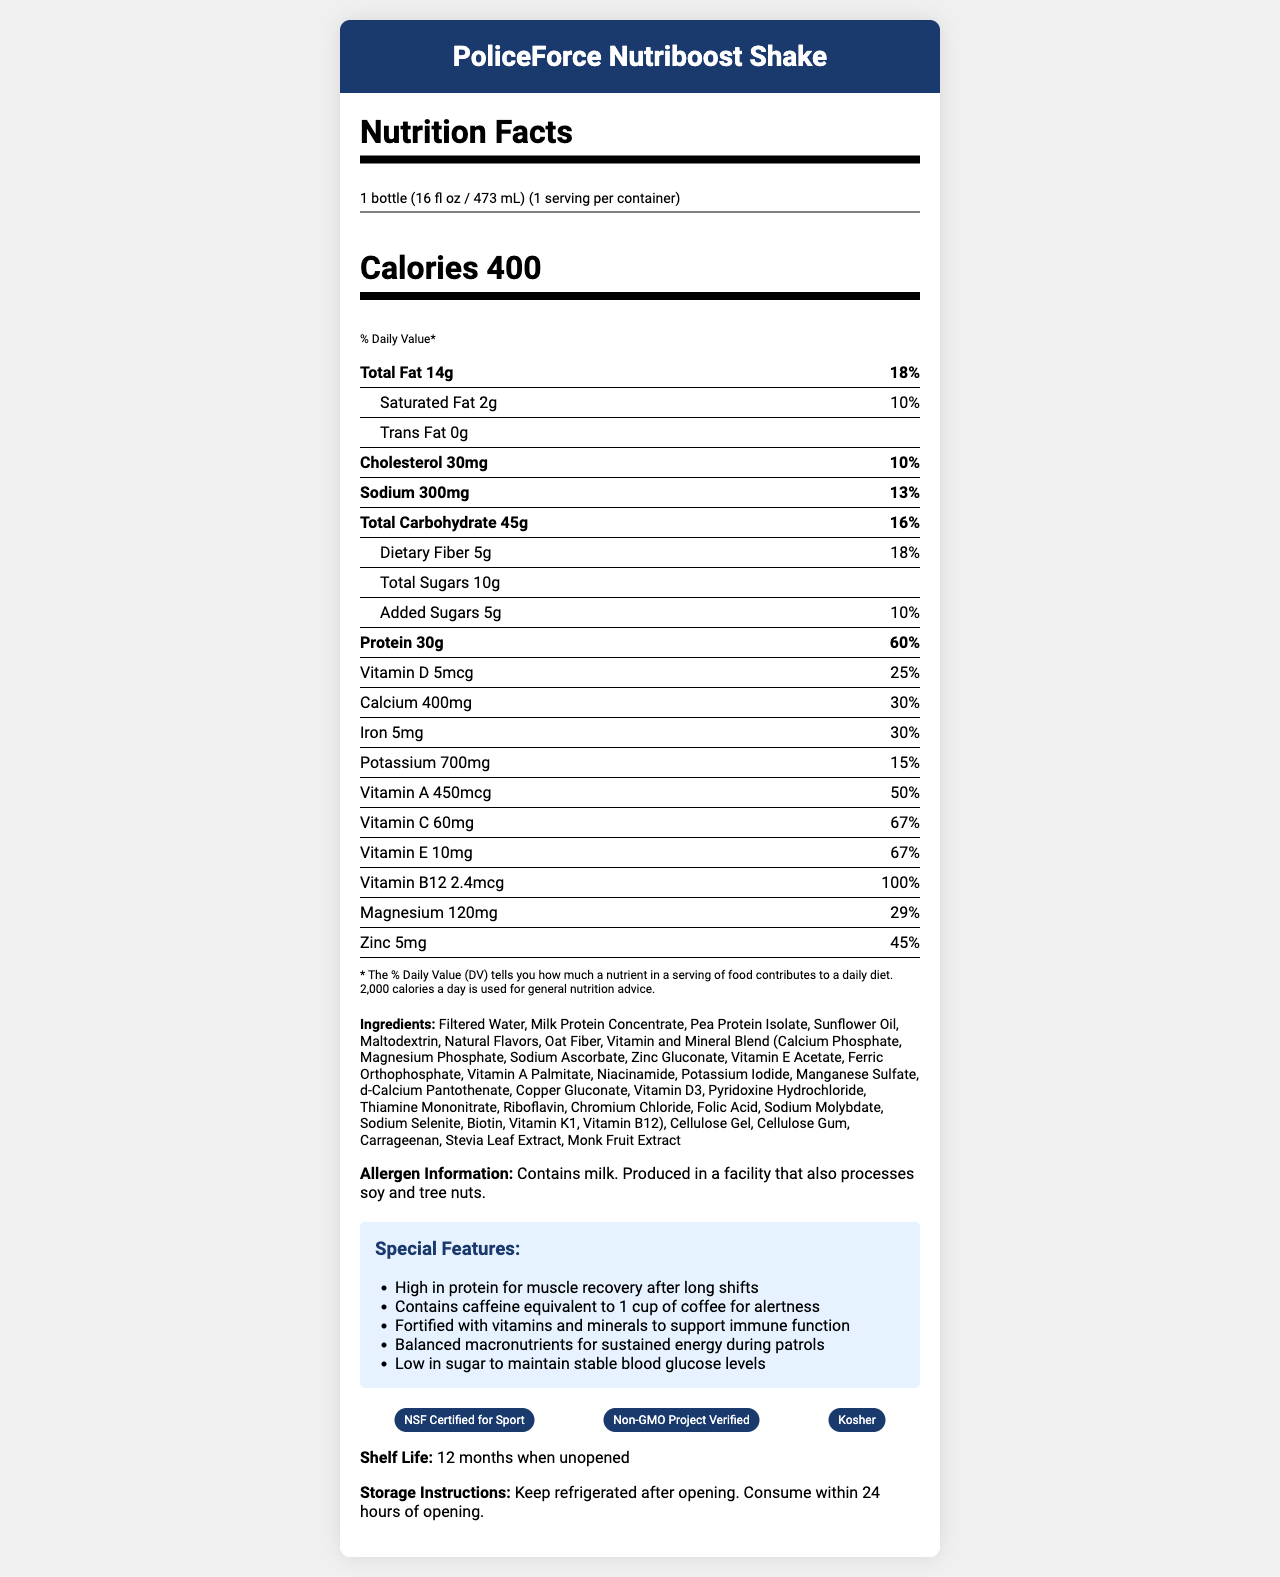what is the serving size of the PoliceForce Nutriboost Shake? The serving size is indicated at the top of the nutrition facts, stating "1 bottle (16 fl oz / 473 mL)"
Answer: 1 bottle (16 fl oz / 473 mL) how many calories are in one serving? The calories per serving are listed as 400 under the "Calories" heading.
Answer: 400 calories What is the percentage daily value of Vitamin B12? The Vitamin B12 percentage daily value is shown as 100% in the nutrient breakdown.
Answer: 100% how much total fat is in a serving? The total fat amount per serving is stated as "14g" in the nutrient list.
Answer: 14g What is the key ingredient listed first in the PoliceForce Nutriboost Shake? The first ingredient listed in the ingredients section is "Filtered Water".
Answer: Filtered Water Which of the following certifications does the PoliceForce Nutriboost Shake have? A. Gluten-Free Certified B. Non-GMO Project Verified C. USDA Organic D. Fair Trade Certified The certifications listed in the document include "Non-GMO Project Verified," which matches option B.
Answer: B What is the amount of dietary fiber per serving? The amount of dietary fiber is specified as 5g in the nutrient details.
Answer: 5g Is the shake high in protein? The shake has 30g of protein, which accounts for 60% of the daily value, indicating it is high in protein.
Answer: Yes Which feature supports muscle recovery for police officers after long shifts? The special feature highlighting muscle recovery mentions "High in protein for muscle recovery after long shifts."
Answer: High in protein for muscle recovery after long shifts does this product contain soy? The document states the shake is "Produced in a facility that also processes soy," but it does not clearly indicate if soy is an ingredient.
Answer: Cannot be determined Summarize the main features of the PoliceForce Nutriboost Shake. The shake is crafted to support the demanding needs of law enforcement personnel with high protein for muscle recovery, caffeine for alertness, and fortified vitamins and minerals. It complies with several certifications ensuring safety and quality.
Answer: The PoliceForce Nutriboost Shake is a nutrient-dense meal replacement designed for law enforcement personnel. It contains 400 calories per serving with 30g of protein, 14g of total fat, and 45g of carbohydrates. It's fortified with essential vitamins and minerals and includes features like muscle recovery support, caffeine for alertness, and balanced macronutrients for sustained energy. The product is NSF Certified for Sport, Non-GMO Project Verified, and Kosher. The shake should be refrigerated after opening and consumed within 24 hours. 